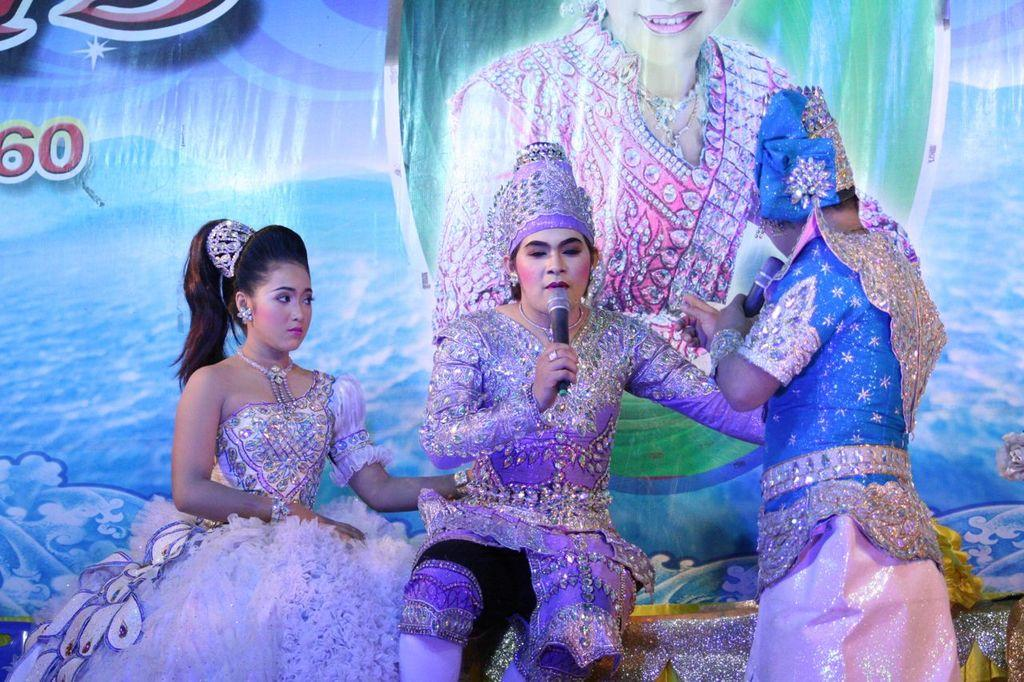How many people are in the image? There are people in the image, but the exact number is not specified. What are the people wearing? The people are wearing different costumes. What objects can be seen in the image that are related to speaking or performing? There are microphones in the image. What can be seen in the background of the image? There is a banner with text in the background of the image. How many pigs are visible in the image? There are no pigs present in the image. What type of pen is being used by the people in the image? There is no pen visible in the image. 